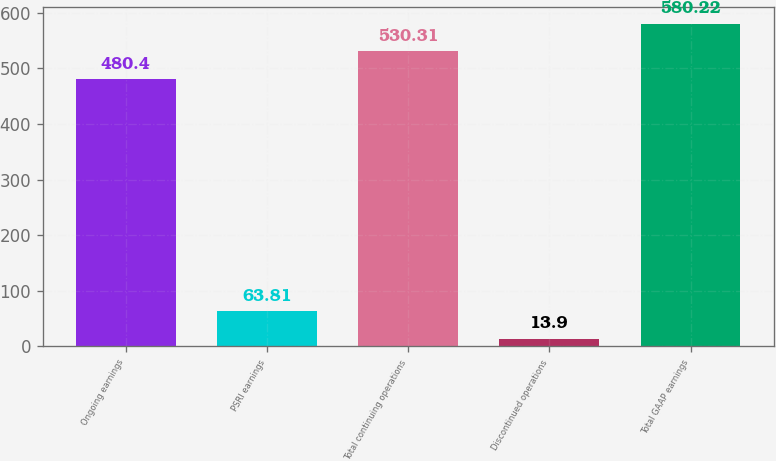Convert chart. <chart><loc_0><loc_0><loc_500><loc_500><bar_chart><fcel>Ongoing earnings<fcel>PSRI earnings<fcel>Total continuing operations<fcel>Discontinued operations<fcel>Total GAAP earnings<nl><fcel>480.4<fcel>63.81<fcel>530.31<fcel>13.9<fcel>580.22<nl></chart> 